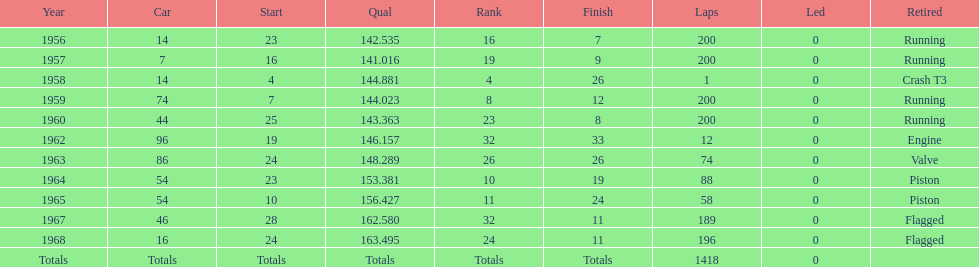How long did bob veith have the number 54 car at the indy 500? 2 years. 